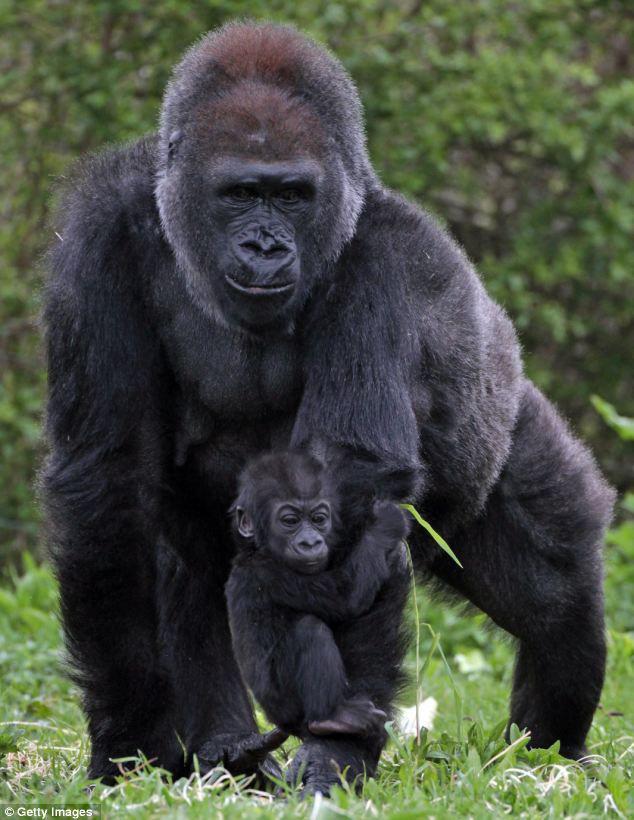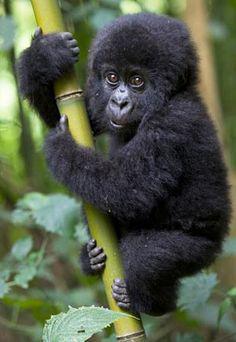The first image is the image on the left, the second image is the image on the right. Given the left and right images, does the statement "There are exactly three gorillas." hold true? Answer yes or no. Yes. The first image is the image on the left, the second image is the image on the right. For the images displayed, is the sentence "In at least one image there are two gorilla one adult holding a single baby." factually correct? Answer yes or no. Yes. 